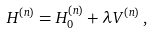<formula> <loc_0><loc_0><loc_500><loc_500>H ^ { ( n ) } = H ^ { ( n ) } _ { 0 } + \lambda V ^ { ( n ) } \, ,</formula> 